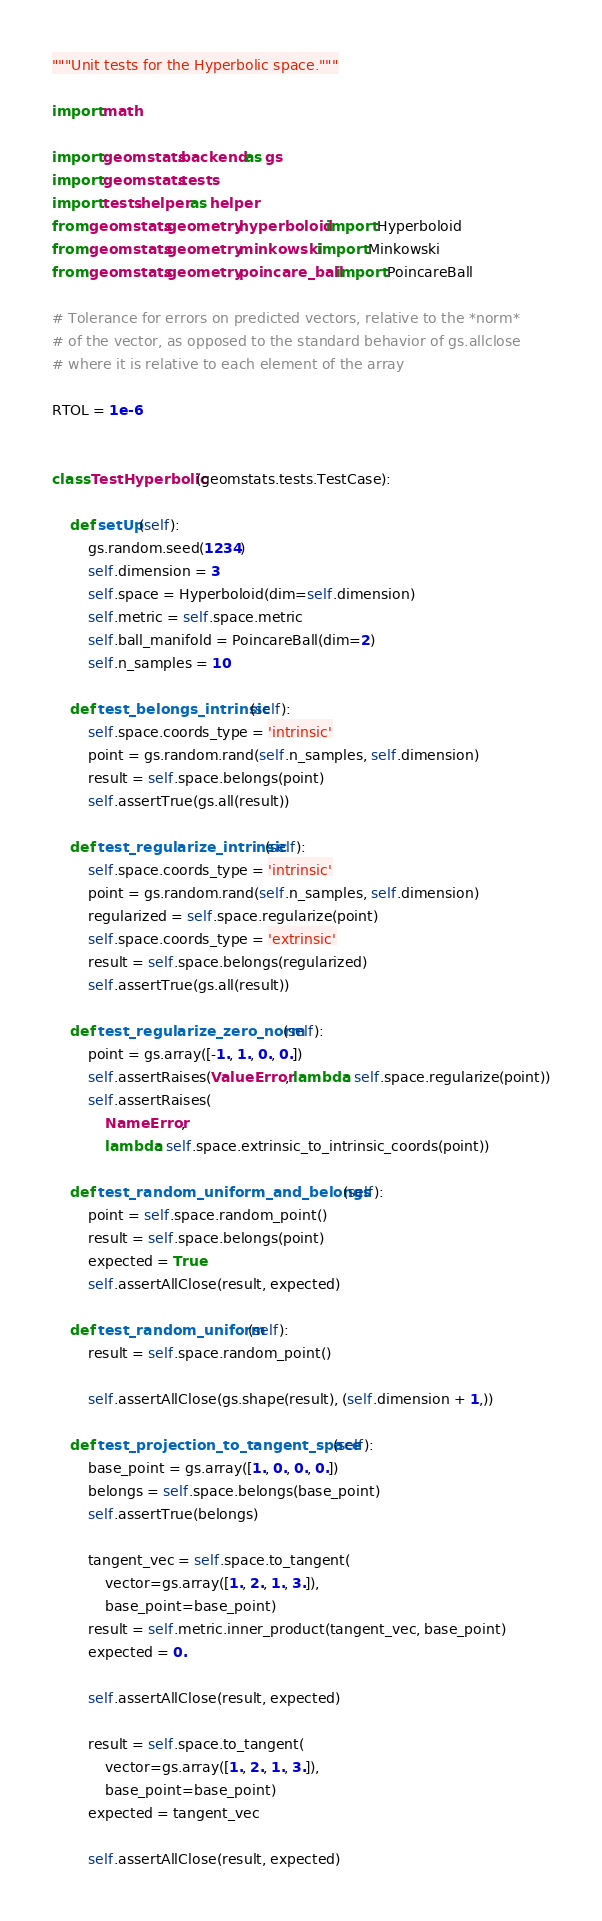<code> <loc_0><loc_0><loc_500><loc_500><_Python_>"""Unit tests for the Hyperbolic space."""

import math

import geomstats.backend as gs
import geomstats.tests
import tests.helper as helper
from geomstats.geometry.hyperboloid import Hyperboloid
from geomstats.geometry.minkowski import Minkowski
from geomstats.geometry.poincare_ball import PoincareBall

# Tolerance for errors on predicted vectors, relative to the *norm*
# of the vector, as opposed to the standard behavior of gs.allclose
# where it is relative to each element of the array

RTOL = 1e-6


class TestHyperbolic(geomstats.tests.TestCase):

    def setUp(self):
        gs.random.seed(1234)
        self.dimension = 3
        self.space = Hyperboloid(dim=self.dimension)
        self.metric = self.space.metric
        self.ball_manifold = PoincareBall(dim=2)
        self.n_samples = 10

    def test_belongs_intrinsic(self):
        self.space.coords_type = 'intrinsic'
        point = gs.random.rand(self.n_samples, self.dimension)
        result = self.space.belongs(point)
        self.assertTrue(gs.all(result))

    def test_regularize_intrinsic(self):
        self.space.coords_type = 'intrinsic'
        point = gs.random.rand(self.n_samples, self.dimension)
        regularized = self.space.regularize(point)
        self.space.coords_type = 'extrinsic'
        result = self.space.belongs(regularized)
        self.assertTrue(gs.all(result))

    def test_regularize_zero_norm(self):
        point = gs.array([-1., 1., 0., 0.])
        self.assertRaises(ValueError, lambda: self.space.regularize(point))
        self.assertRaises(
            NameError,
            lambda: self.space.extrinsic_to_intrinsic_coords(point))

    def test_random_uniform_and_belongs(self):
        point = self.space.random_point()
        result = self.space.belongs(point)
        expected = True
        self.assertAllClose(result, expected)

    def test_random_uniform(self):
        result = self.space.random_point()

        self.assertAllClose(gs.shape(result), (self.dimension + 1,))

    def test_projection_to_tangent_space(self):
        base_point = gs.array([1., 0., 0., 0.])
        belongs = self.space.belongs(base_point)
        self.assertTrue(belongs)

        tangent_vec = self.space.to_tangent(
            vector=gs.array([1., 2., 1., 3.]),
            base_point=base_point)
        result = self.metric.inner_product(tangent_vec, base_point)
        expected = 0.

        self.assertAllClose(result, expected)

        result = self.space.to_tangent(
            vector=gs.array([1., 2., 1., 3.]),
            base_point=base_point)
        expected = tangent_vec

        self.assertAllClose(result, expected)
</code> 